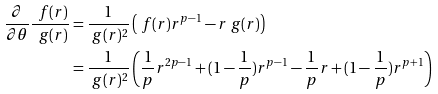<formula> <loc_0><loc_0><loc_500><loc_500>\frac { \partial } { \partial \theta } \frac { \ f ( r ) } { \ g ( r ) } & = \frac { 1 } { \ g ( r ) ^ { 2 } } \left ( \ f ( r ) r ^ { p - 1 } - r \ g ( r ) \right ) \\ & = \frac { 1 } { \ g ( r ) ^ { 2 } } \left ( \frac { 1 } { p } r ^ { 2 p - 1 } + ( 1 - \frac { 1 } { p } ) r ^ { p - 1 } - \frac { 1 } { p } r + ( 1 - \frac { 1 } { p } ) r ^ { p + 1 } \right )</formula> 